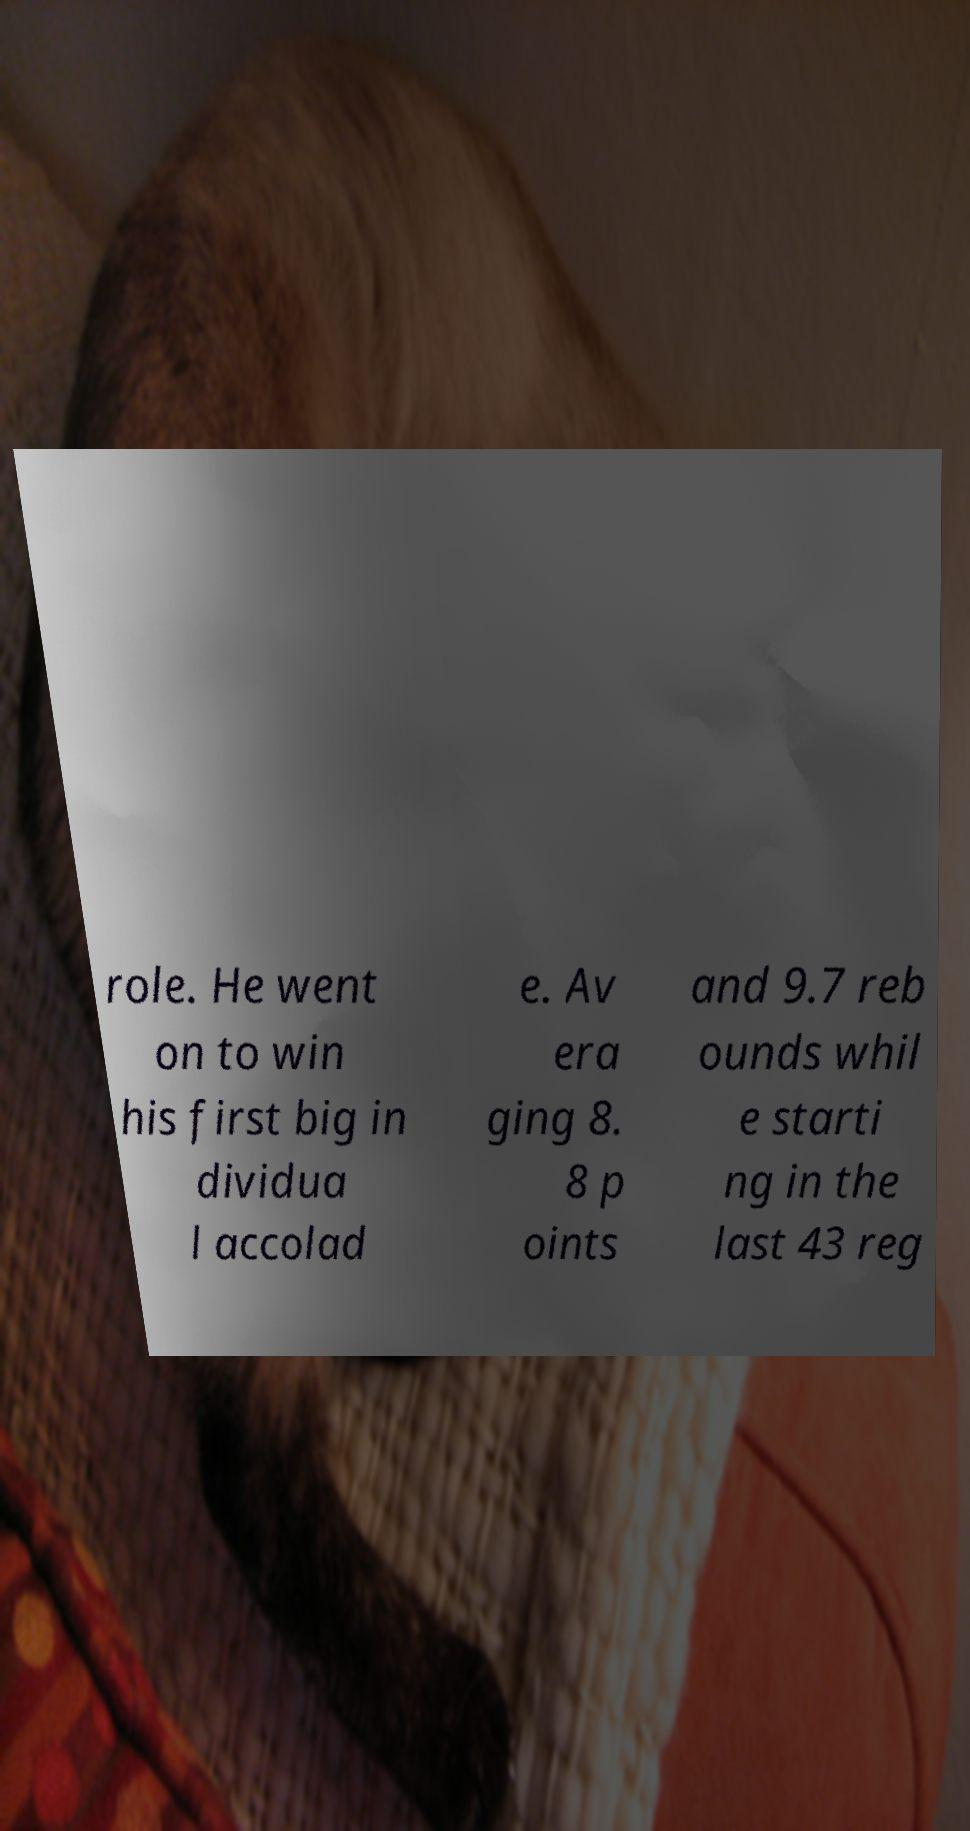Can you accurately transcribe the text from the provided image for me? role. He went on to win his first big in dividua l accolad e. Av era ging 8. 8 p oints and 9.7 reb ounds whil e starti ng in the last 43 reg 